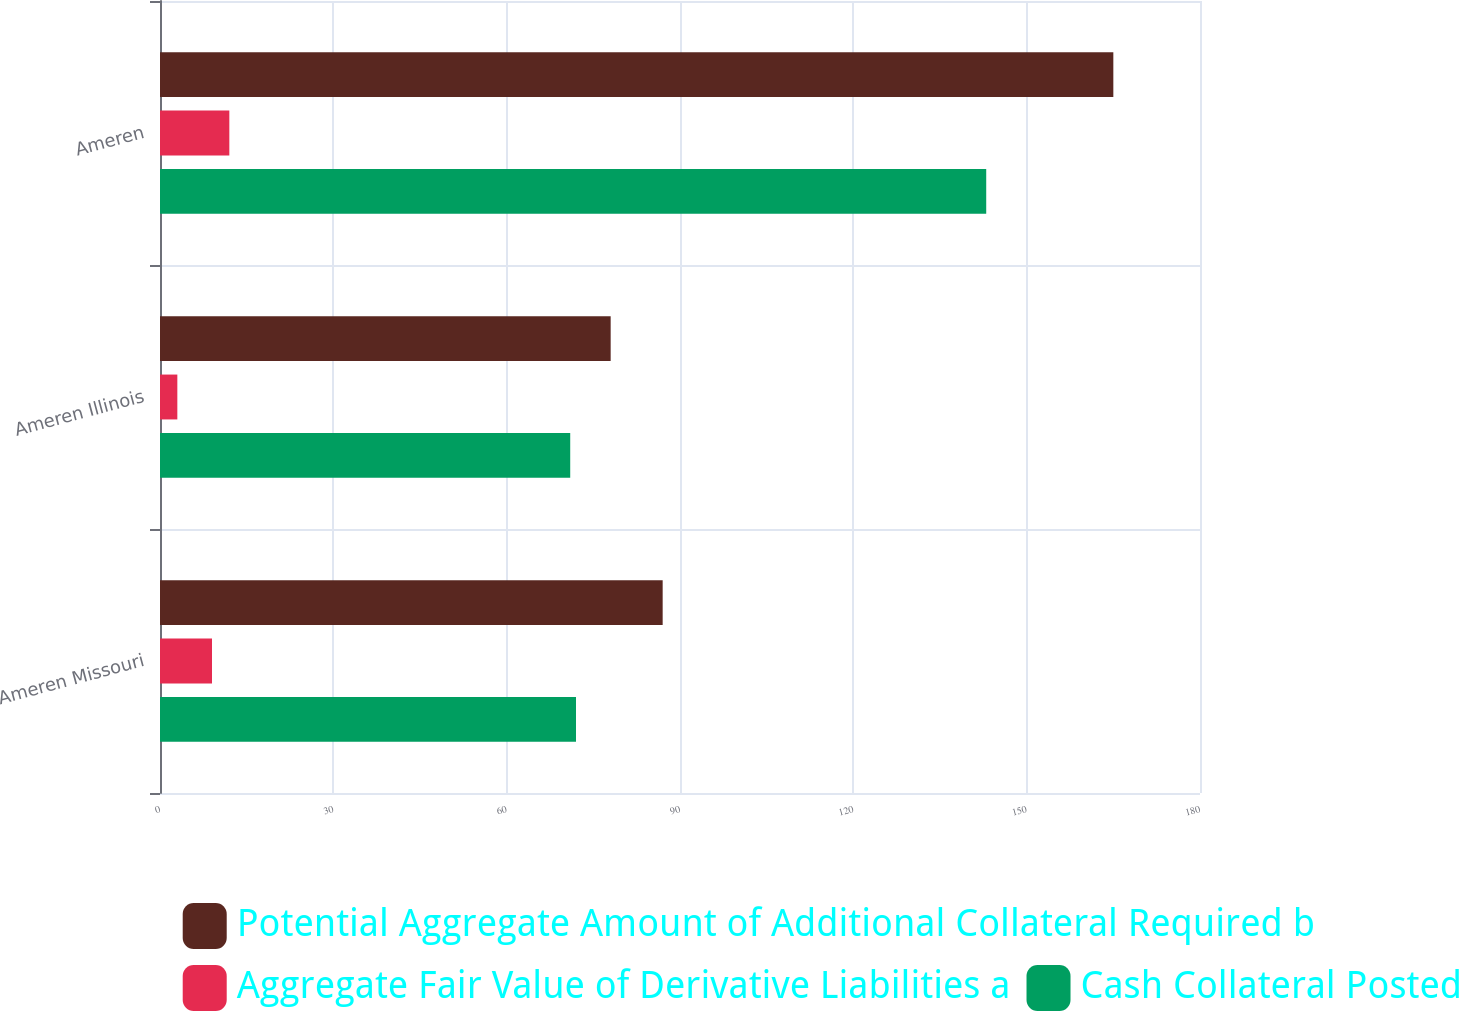Convert chart to OTSL. <chart><loc_0><loc_0><loc_500><loc_500><stacked_bar_chart><ecel><fcel>Ameren Missouri<fcel>Ameren Illinois<fcel>Ameren<nl><fcel>Potential Aggregate Amount of Additional Collateral Required b<fcel>87<fcel>78<fcel>165<nl><fcel>Aggregate Fair Value of Derivative Liabilities a<fcel>9<fcel>3<fcel>12<nl><fcel>Cash Collateral Posted<fcel>72<fcel>71<fcel>143<nl></chart> 